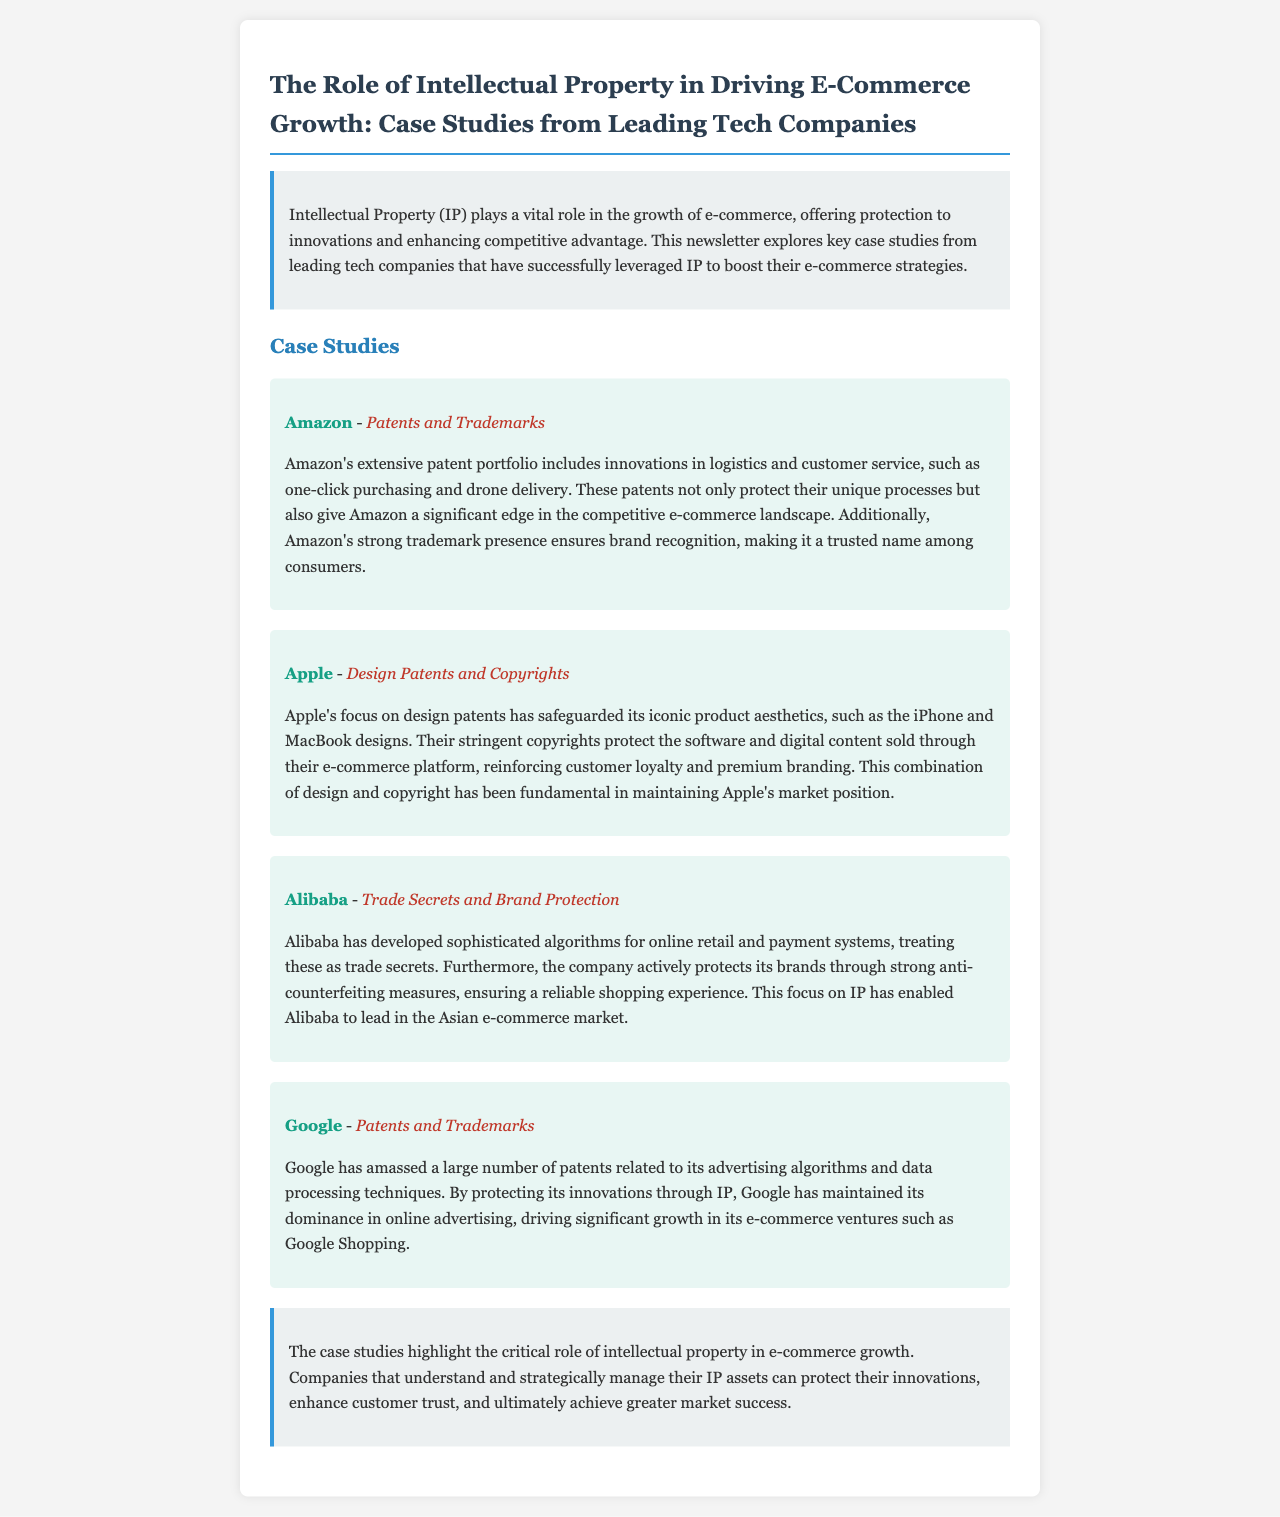What IP strategies does Amazon use? The document mentions that Amazon uses patents and trademarks as its IP strategies.
Answer: Patents and Trademarks What specific innovation is protected by Amazon's patents? One-click purchasing is an innovation in logistics and customer service that is referenced in the document.
Answer: One-click purchasing Which company focuses on design patents? The document indicates that Apple is focused on design patents.
Answer: Apple What IP type does Alibaba prioritize to protect its algorithms? The document states that Alibaba treats its algorithms as trade secrets.
Answer: Trade Secrets How does Apple reinforce customer loyalty? The document explains that Apple reinforces customer loyalty through stringent copyrights protecting software and digital content.
Answer: Copyrights What is the competitive edge for Amazon in e-commerce? Amazon's significant edge is derived from its extensive patent portfolio, which protects unique processes.
Answer: Extensive patent portfolio What does Google mainly protect through its patents? Google protects its advertising algorithms and data processing techniques through its patents.
Answer: Advertising algorithms and data processing techniques What overarching theme is presented in the conclusion of the document? The conclusion highlights the critical role of intellectual property in e-commerce growth.
Answer: Critical role of intellectual property Which market does Alibaba lead in e-commerce? The document specifies that Alibaba leads in the Asian e-commerce market.
Answer: Asian e-commerce market 